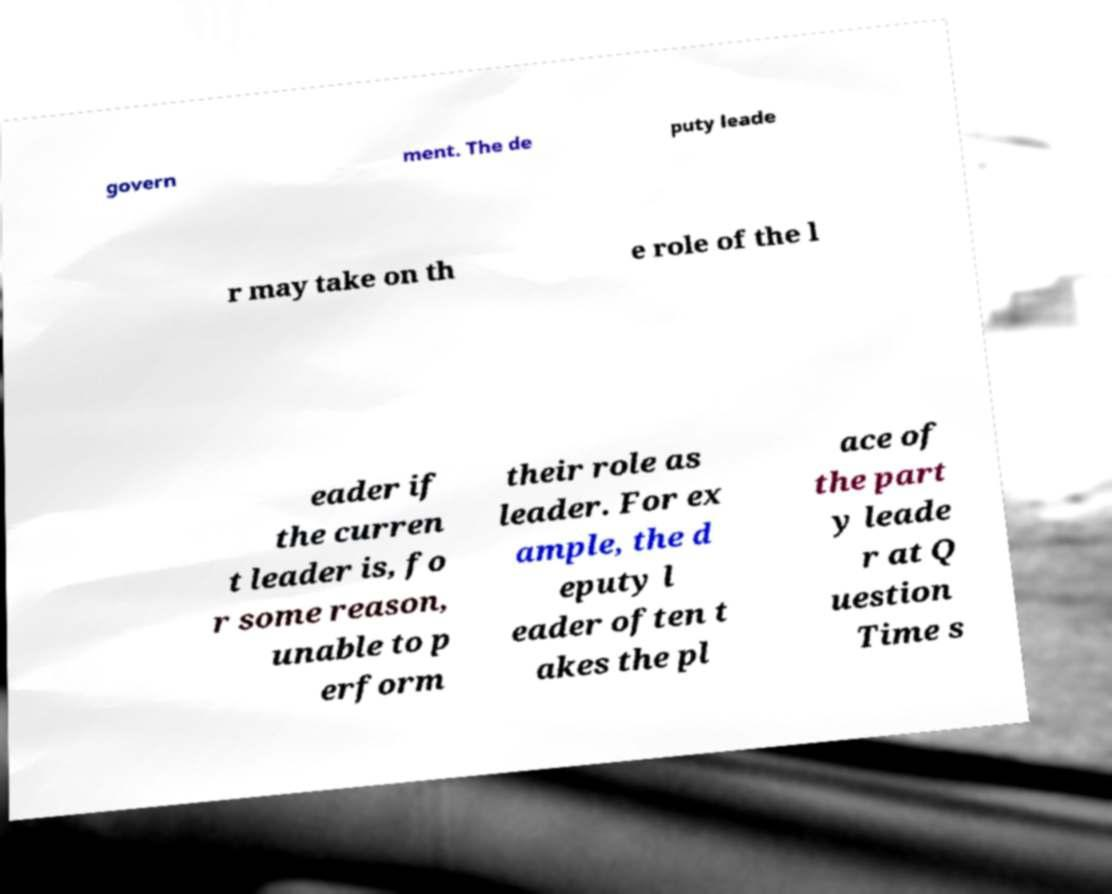Can you accurately transcribe the text from the provided image for me? govern ment. The de puty leade r may take on th e role of the l eader if the curren t leader is, fo r some reason, unable to p erform their role as leader. For ex ample, the d eputy l eader often t akes the pl ace of the part y leade r at Q uestion Time s 